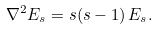<formula> <loc_0><loc_0><loc_500><loc_500>{ \nabla ^ { 2 } E _ { s } = s ( s - 1 ) \, E _ { s } . }</formula> 